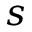Convert formula to latex. <formula><loc_0><loc_0><loc_500><loc_500>s</formula> 